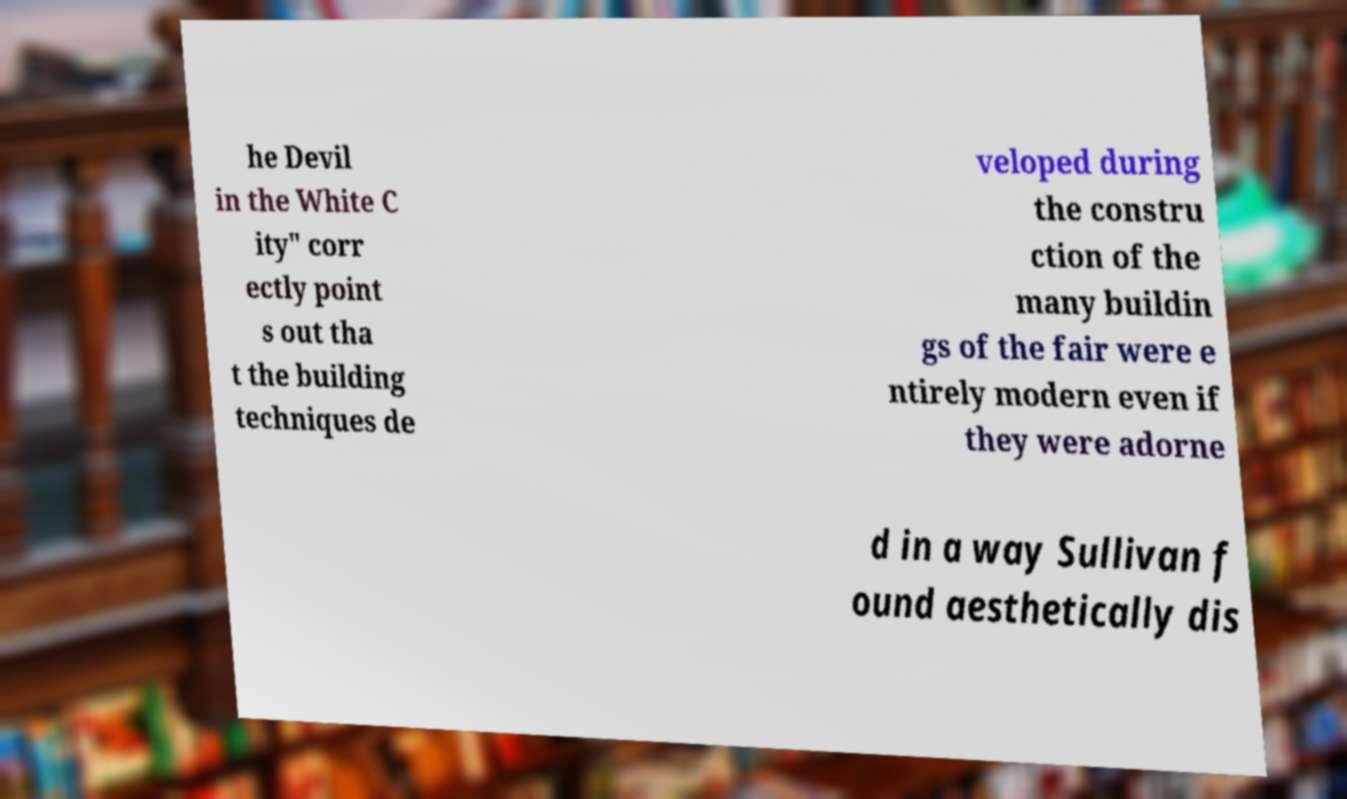I need the written content from this picture converted into text. Can you do that? he Devil in the White C ity" corr ectly point s out tha t the building techniques de veloped during the constru ction of the many buildin gs of the fair were e ntirely modern even if they were adorne d in a way Sullivan f ound aesthetically dis 